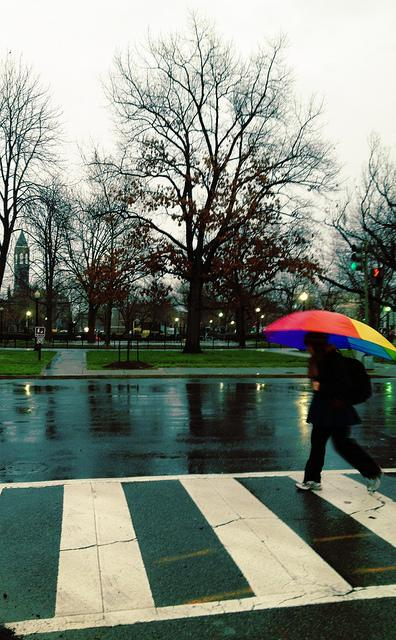What is the person walking on? Please explain your reasoning. street. It is a hard paved surface. there is a crosswalk painted on it. 